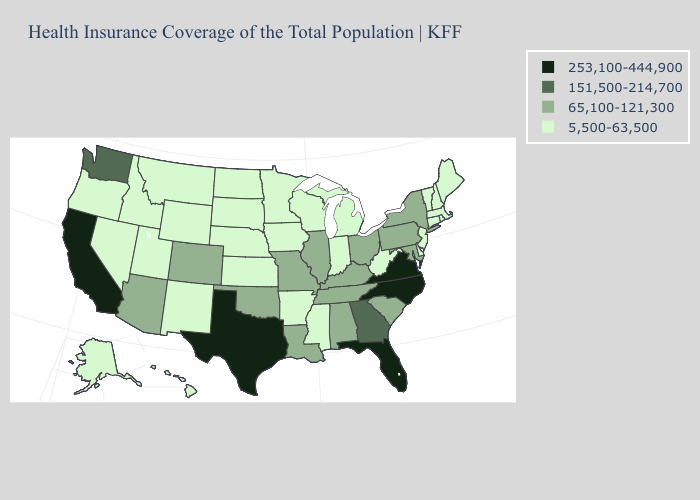Name the states that have a value in the range 5,500-63,500?
Keep it brief. Alaska, Arkansas, Connecticut, Delaware, Hawaii, Idaho, Indiana, Iowa, Kansas, Maine, Massachusetts, Michigan, Minnesota, Mississippi, Montana, Nebraska, Nevada, New Hampshire, New Jersey, New Mexico, North Dakota, Oregon, Rhode Island, South Dakota, Utah, Vermont, West Virginia, Wisconsin, Wyoming. Name the states that have a value in the range 65,100-121,300?
Be succinct. Alabama, Arizona, Colorado, Illinois, Kentucky, Louisiana, Maryland, Missouri, New York, Ohio, Oklahoma, Pennsylvania, South Carolina, Tennessee. Does Delaware have the lowest value in the South?
Answer briefly. Yes. What is the lowest value in the USA?
Give a very brief answer. 5,500-63,500. Name the states that have a value in the range 253,100-444,900?
Short answer required. California, Florida, North Carolina, Texas, Virginia. What is the highest value in the South ?
Keep it brief. 253,100-444,900. What is the highest value in the USA?
Short answer required. 253,100-444,900. Does Rhode Island have the lowest value in the USA?
Be succinct. Yes. What is the lowest value in states that border Delaware?
Write a very short answer. 5,500-63,500. What is the value of South Dakota?
Answer briefly. 5,500-63,500. Does Hawaii have the lowest value in the West?
Concise answer only. Yes. Does Minnesota have the highest value in the MidWest?
Give a very brief answer. No. Name the states that have a value in the range 5,500-63,500?
Be succinct. Alaska, Arkansas, Connecticut, Delaware, Hawaii, Idaho, Indiana, Iowa, Kansas, Maine, Massachusetts, Michigan, Minnesota, Mississippi, Montana, Nebraska, Nevada, New Hampshire, New Jersey, New Mexico, North Dakota, Oregon, Rhode Island, South Dakota, Utah, Vermont, West Virginia, Wisconsin, Wyoming. What is the value of Maryland?
Concise answer only. 65,100-121,300. Among the states that border Virginia , does Maryland have the lowest value?
Short answer required. No. 